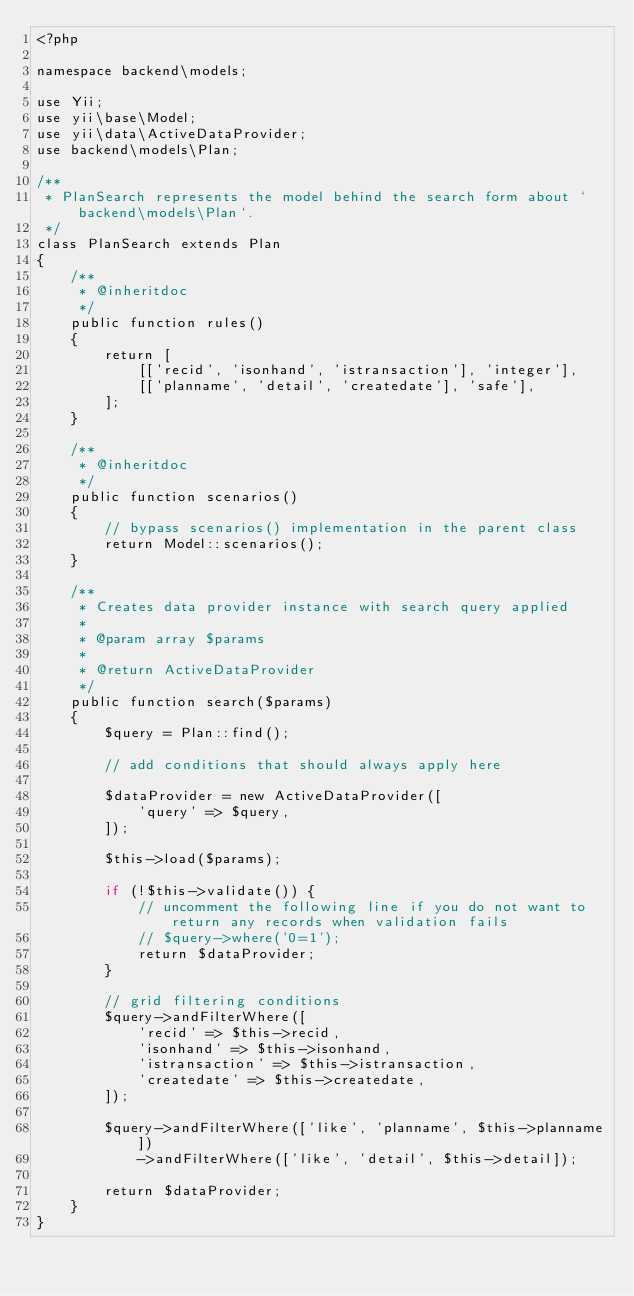Convert code to text. <code><loc_0><loc_0><loc_500><loc_500><_PHP_><?php

namespace backend\models;

use Yii;
use yii\base\Model;
use yii\data\ActiveDataProvider;
use backend\models\Plan;

/**
 * PlanSearch represents the model behind the search form about `backend\models\Plan`.
 */
class PlanSearch extends Plan
{
    /**
     * @inheritdoc
     */
    public function rules()
    {
        return [
            [['recid', 'isonhand', 'istransaction'], 'integer'],
            [['planname', 'detail', 'createdate'], 'safe'],
        ];
    }

    /**
     * @inheritdoc
     */
    public function scenarios()
    {
        // bypass scenarios() implementation in the parent class
        return Model::scenarios();
    }

    /**
     * Creates data provider instance with search query applied
     *
     * @param array $params
     *
     * @return ActiveDataProvider
     */
    public function search($params)
    {
        $query = Plan::find();

        // add conditions that should always apply here

        $dataProvider = new ActiveDataProvider([
            'query' => $query,
        ]);

        $this->load($params);

        if (!$this->validate()) {
            // uncomment the following line if you do not want to return any records when validation fails
            // $query->where('0=1');
            return $dataProvider;
        }

        // grid filtering conditions
        $query->andFilterWhere([
            'recid' => $this->recid,
            'isonhand' => $this->isonhand,
            'istransaction' => $this->istransaction,
            'createdate' => $this->createdate,
        ]);

        $query->andFilterWhere(['like', 'planname', $this->planname])
            ->andFilterWhere(['like', 'detail', $this->detail]);

        return $dataProvider;
    }
}
</code> 